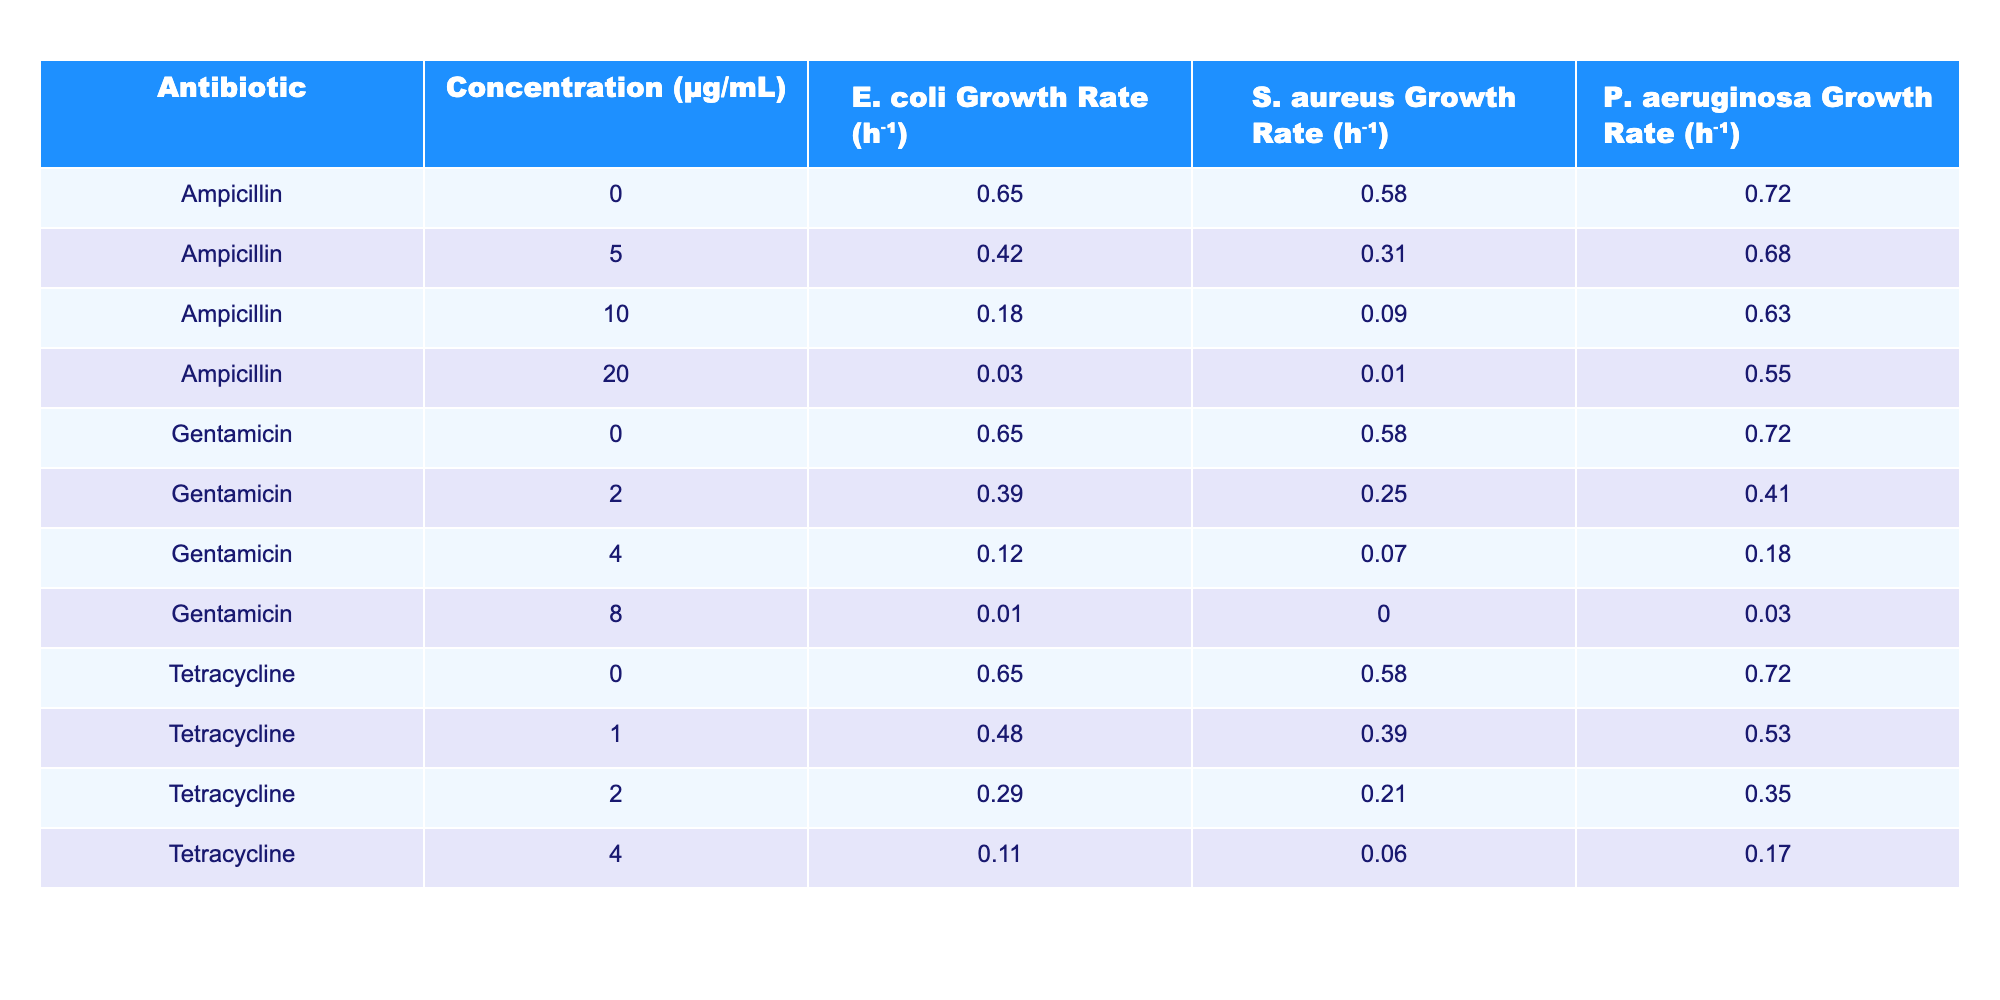What is the growth rate of E. coli at an ampicillin concentration of 10 μg/mL? The table shows the E. coli growth rate at various ampicillin concentrations. For the concentration of 10 μg/mL, the growth rate is specifically listed in the row corresponding to that concentration. In that row, the value is 0.18 h⁻¹.
Answer: 0.18 h⁻¹ Is the growth rate of S. aureus higher at a concentration of 5 μg/mL of ampicillin compared to 2 μg/mL of gentamicin? By referring to the table, we find that S. aureus growth rate at 5 μg/mL of ampicillin is 0.31 h⁻¹, whereas at 2 μg/mL of gentamicin, it is 0.25 h⁻¹. Since 0.31 is greater than 0.25, the statement is true.
Answer: Yes What is the difference in growth rates of P. aeruginosa between 0 μg/mL and 20 μg/mL of ampicillin? At 0 μg/mL of ampicillin, the growth rate of P. aeruginosa is 0.72 h⁻¹ and at 20 μg/mL, it is 0.55 h⁻¹. We calculate the difference as 0.72 - 0.55 = 0.17 h⁻¹.
Answer: 0.17 h⁻¹ What is the average growth rate of E. coli across all concentrations of tetracycline? The growth rates of E. coli for tetracycline at all concentrations are 0.65, 0.48, 0.29, and 0.11. Summing these values gives 0.65 + 0.48 + 0.29 + 0.11 = 1.53. There are 4 data points, so the average is 1.53 / 4 = 0.3825 h⁻¹.
Answer: 0.3825 h⁻¹ Is the minimum growth rate of E. coli observed at any tested concentration of gentamicin greater than 0.01 h⁻¹? Referring to the table, the lowest growth rate for E. coli under gentamicin is found at 8 μg/mL, which is recorded as 0.01 h⁻¹. Since the minimum growth rate is equal to 0.01 h⁻¹, it is not greater than 0.01 h⁻¹.
Answer: No What is the highest growth rate of S. aureus in the presence of antibiotics, and which antibiotic and concentration correspond to this value? The highest growth rate of S. aureus in the table is found at 0 μg/mL concentration for both ampicillin and gentamicin, and it is 0.58 h⁻¹. This means that the growth rate does not change at either of these concentrations as both have the same value.
Answer: 0.58 h⁻¹ (Ampicillin, Gentamicin at 0 μg/mL) How does the growth rate of P. aeruginosa at 2 μg/mL of tetracycline compare to its growth rate at 10 μg/mL of ampicillin? The P. aeruginosa growth rate at 2 μg/mL of tetracycline is 0.35 h⁻¹, while at 10 μg/mL of ampicillin, it is 0.63 h⁻¹. To compare, we see that 0.35 h⁻¹ is less than 0.63 h⁻¹.
Answer: Lower What is the total growth rate of E. coli at all concentrations tested for gentamicin? The growth rates of E. coli under gentamicin are 0.65, 0.39, 0.12, and 0.01 respectively across the concentrations. Summing these values gives 0.65 + 0.39 + 0.12 + 0.01 = 1.17 h⁻¹.
Answer: 1.17 h⁻¹ Is there a concentration of tetracycline that completely inhibits the growth of either E. coli or S. aureus? Checking the table, the lowest growth rate listed for both E. coli (at 4 μg/mL) and S. aureus (at 4 μg/mL as well) is non-zero (0.11 h⁻¹ and 0.06 h⁻¹ respectively), hence there is no concentration of tetracycline completely inhibiting their growth.
Answer: No 